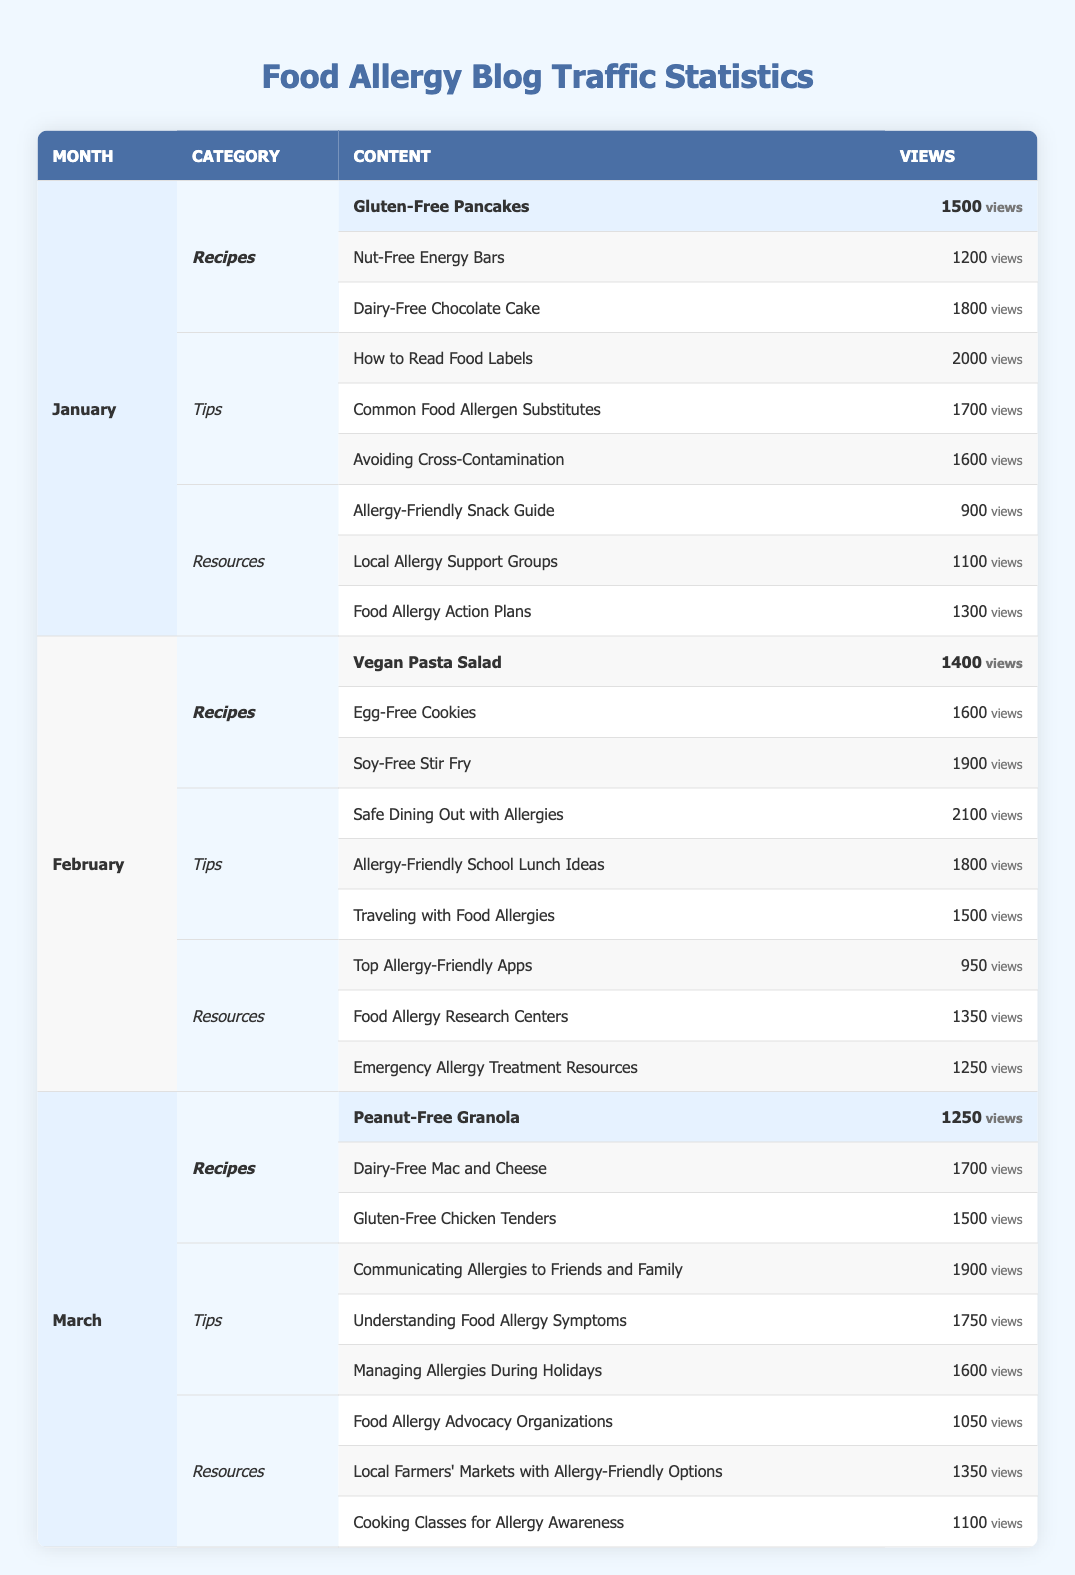What is the total number of views for all recipes in January? To find the total views for all recipes in January, we look at the views for each recipe: Gluten-Free Pancakes (1500), Nut-Free Energy Bars (1200), and Dairy-Free Chocolate Cake (1800). Summing them gives 1500 + 1200 + 1800 = 4500 views.
Answer: 4500 Which tip received the highest views in February? In February, the tips and their views are: Safe Dining Out with Allergies (2100), Allergy-Friendly School Lunch Ideas (1800), and Traveling with Food Allergies (1500). The highest is 2100 views for Safe Dining Out with Allergies.
Answer: 2100 Did any resource in January have more views than the Allergy-Friendly Snack Guide? The views for the resources in January are: Allergy-Friendly Snack Guide (900), Local Allergy Support Groups (1100), and Food Allergy Action Plans (1300). Both Local Allergy Support Groups (1100) and Food Allergy Action Plans (1300) have more views than 900.
Answer: Yes What is the average number of views for recipes across all three months? The total views for recipes in January are 4500, in February are 4900 (1400 + 1600 + 1900), and in March are 4450 (1250 + 1700 + 1500). Summing these values gives 4500 + 4900 + 4450 = 13850 views. There are 9 recipes total (3 per month), so the average is 13850 / 9 ≈ 1538.89.
Answer: 1538.89 Which month had the most views for resources? The total views for resources are: January (900 + 1100 + 1300 = 3300), February (950 + 1350 + 1250 = 3550), and March (1050 + 1350 + 1100 = 3500). February had the highest total of 3550 views for resources.
Answer: February What is the combined total number of views for tips in March? The views for tips in March are: Communicating Allergies to Friends and Family (1900), Understanding Food Allergy Symptoms (1750), and Managing Allergies During Holidays (1600). Adding them up gives 1900 + 1750 + 1600 = 5250 views for tips in March.
Answer: 5250 Which recipe had the least views in January? The recipes in January and their views are: Gluten-Free Pancakes (1500), Nut-Free Energy Bars (1200), and Dairy-Free Chocolate Cake (1800). The least views are for Nut-Free Energy Bars at 1200.
Answer: Nut-Free Energy Bars Is the total number of views for tips in February greater than that for January? The total views for tips in January are 2000 + 1700 + 1600 = 5300, while in February it is 2100 + 1800 + 1500 = 5400. For February, 5400 is greater than 5300 for January.
Answer: Yes How many more views did the top recipe in February receive than the top recipe in January? The top recipe in February is Soy-Free Stir Fry with 1900 views, and the top recipe in January is Dairy-Free Chocolate Cake with 1800 views. The difference is 1900 - 1800 = 100 views more for February's top recipe.
Answer: 100 